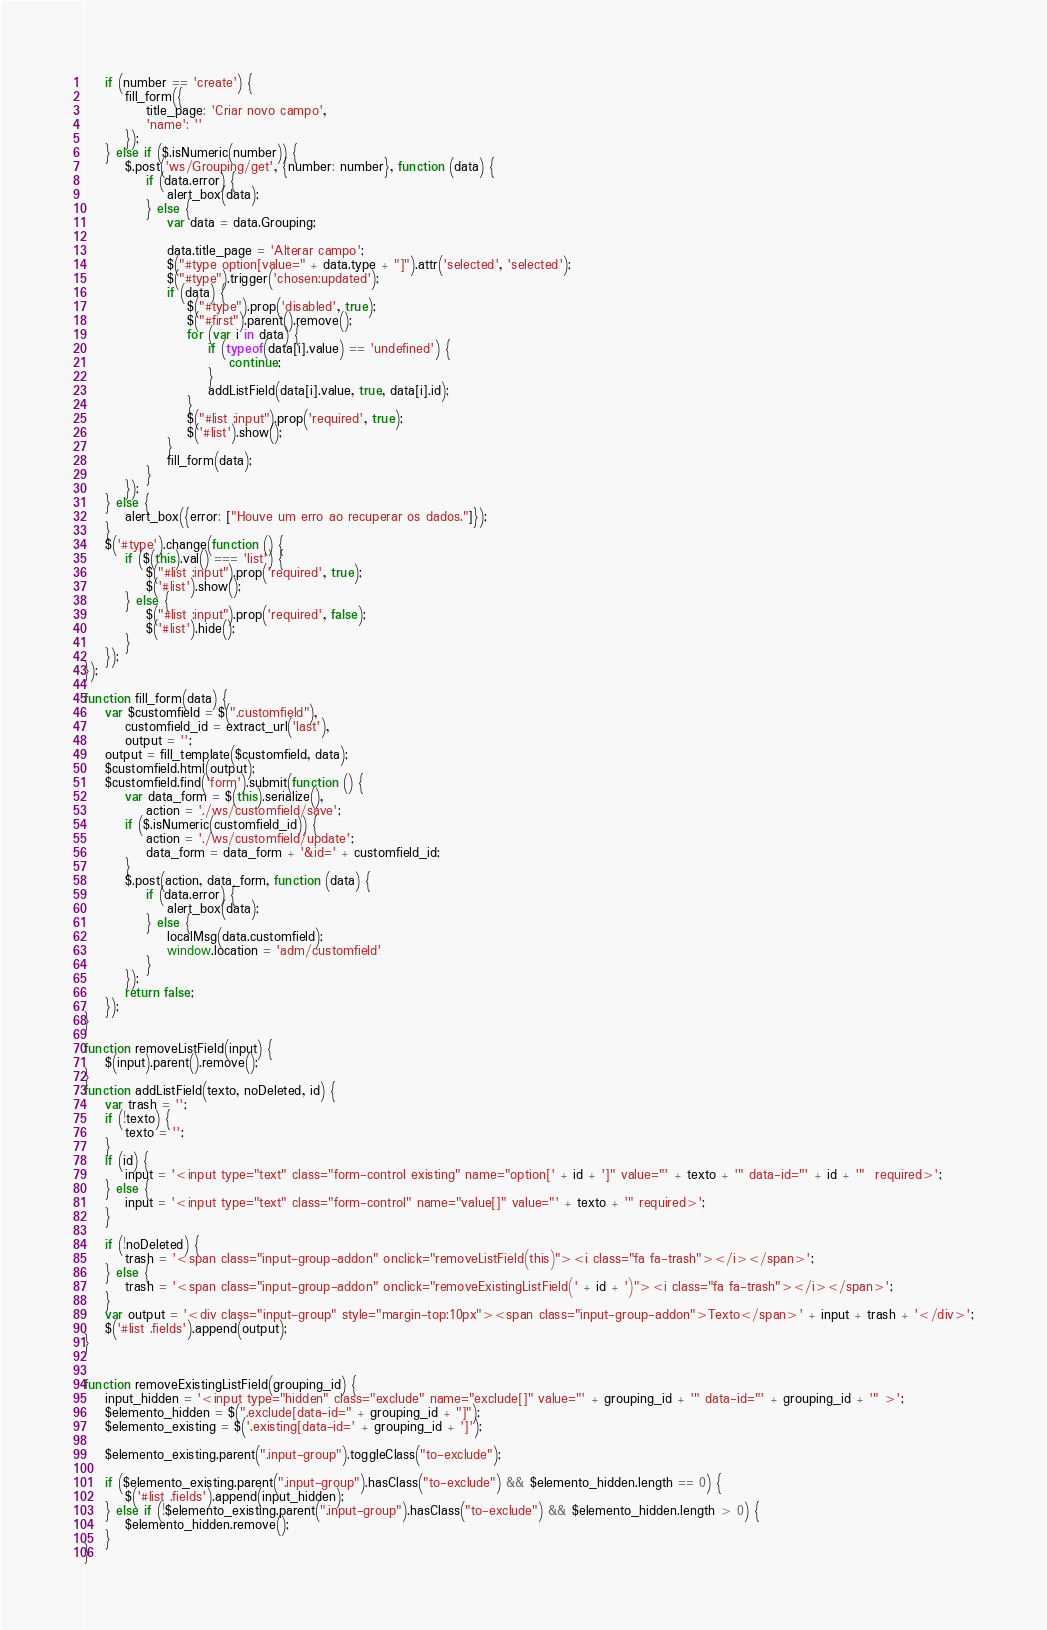Convert code to text. <code><loc_0><loc_0><loc_500><loc_500><_JavaScript_>    if (number == 'create') {
        fill_form({
            title_page: 'Criar novo campo',
            'name': ''
        });
    } else if ($.isNumeric(number)) {
        $.post('ws/Grouping/get', {number: number}, function (data) {
            if (data.error) {
                alert_box(data);
            } else {
                var data = data.Grouping;

                data.title_page = 'Alterar campo';
                $("#type option[value=" + data.type + "]").attr('selected', 'selected');
                $("#type").trigger('chosen:updated');
                if (data) {
                    $("#type").prop('disabled', true);
                    $("#first").parent().remove();
                    for (var i in data) {
                        if (typeof(data[i].value) == 'undefined') {
                            continue;
                        }
                        addListField(data[i].value, true, data[i].id);
                    }
                    $("#list :input").prop('required', true);
                    $('#list').show();
                }
                fill_form(data);
            }
        });
    } else {
        alert_box({error: ["Houve um erro ao recuperar os dados."]});
    }
    $('#type').change(function () {
        if ($(this).val() === 'list') {
            $("#list :input").prop('required', true);
            $('#list').show();
        } else {
            $("#list :input").prop('required', false);
            $('#list').hide();
        }
    });
});

function fill_form(data) {
    var $customfield = $(".customfield"),
        customfield_id = extract_url('last'),
        output = '';
    output = fill_template($customfield, data);
    $customfield.html(output);
    $customfield.find('form').submit(function () {
        var data_form = $(this).serialize(),
            action = './ws/customfield/save';
        if ($.isNumeric(customfield_id)) {
            action = './ws/customfield/update';
            data_form = data_form + '&id=' + customfield_id;
        }
        $.post(action, data_form, function (data) {
            if (data.error) {
                alert_box(data);
            } else {
                localMsg(data.customfield);
                window.location = 'adm/customfield'
            }
        });
        return false;
    });
}

function removeListField(input) {
    $(input).parent().remove();
}
function addListField(texto, noDeleted, id) {
    var trash = '';
    if (!texto) {
        texto = '';
    }
    if (id) {
        input = '<input type="text" class="form-control existing" name="option[' + id + ']" value="' + texto + '" data-id="' + id + '"  required>';
    } else {
        input = '<input type="text" class="form-control" name="value[]" value="' + texto + '" required>';
    }

    if (!noDeleted) {
        trash = '<span class="input-group-addon" onclick="removeListField(this)"><i class="fa fa-trash"></i></span>';
    } else {
        trash = '<span class="input-group-addon" onclick="removeExistingListField(' + id + ')"><i class="fa fa-trash"></i></span>';
    }
    var output = '<div class="input-group" style="margin-top:10px"><span class="input-group-addon">Texto</span>' + input + trash + '</div>';
    $('#list .fields').append(output);
}


function removeExistingListField(grouping_id) {
    input_hidden = '<input type="hidden" class="exclude" name="exclude[]" value="' + grouping_id + '" data-id="' + grouping_id + '" >';
    $elemento_hidden = $(".exclude[data-id=" + grouping_id + "]");
    $elemento_existing = $('.existing[data-id=' + grouping_id + ']');

    $elemento_existing.parent(".input-group").toggleClass("to-exclude");

    if ($elemento_existing.parent(".input-group").hasClass("to-exclude") && $elemento_hidden.length == 0) {
        $('#list .fields').append(input_hidden);
    } else if (!$elemento_existing.parent(".input-group").hasClass("to-exclude") && $elemento_hidden.length > 0) {
        $elemento_hidden.remove();
    }
}</code> 